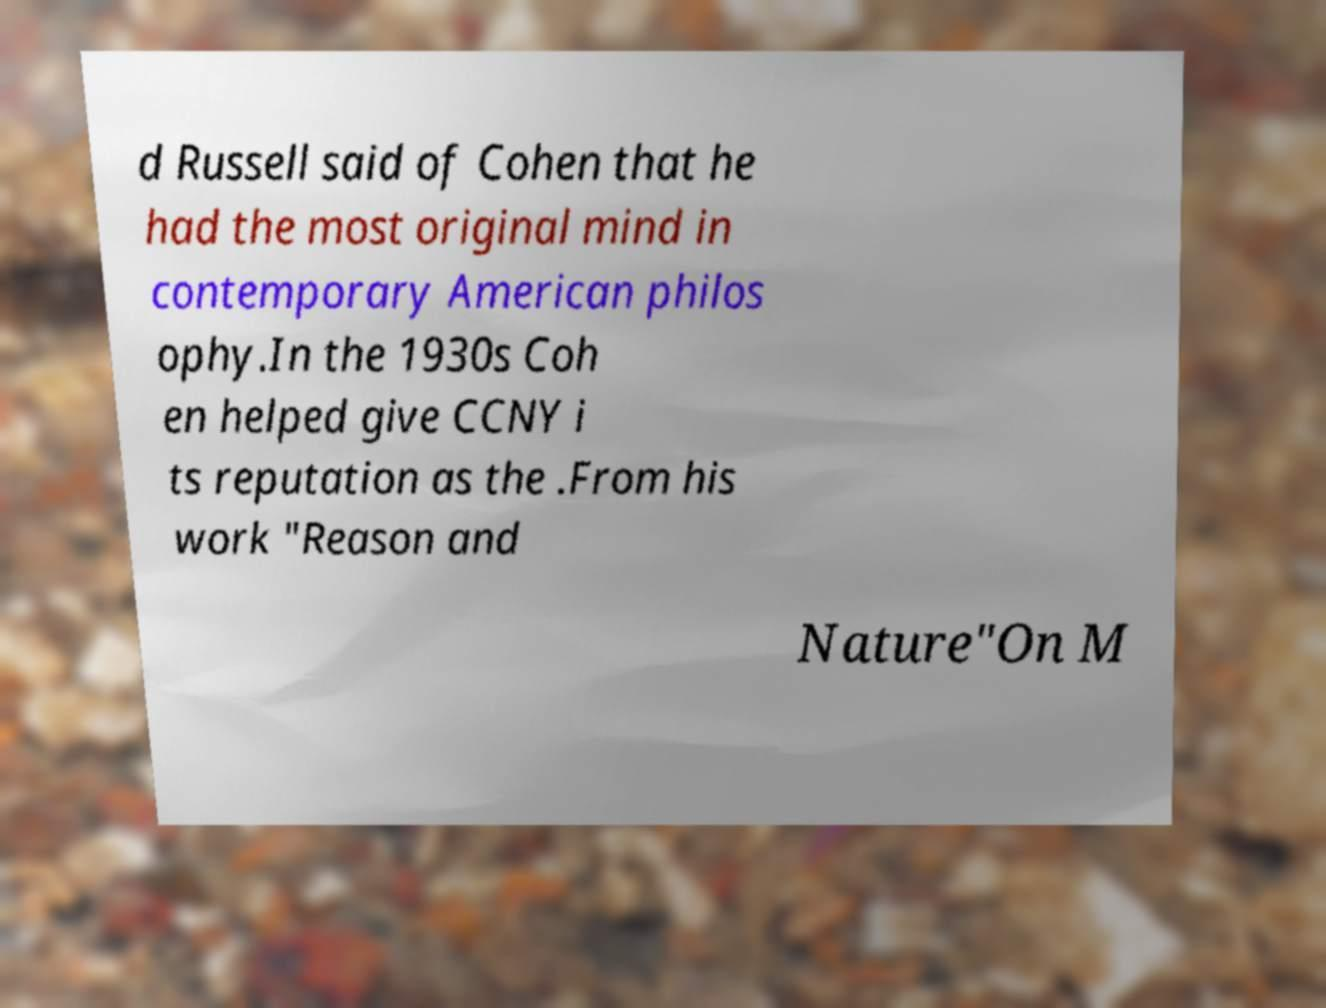Could you extract and type out the text from this image? d Russell said of Cohen that he had the most original mind in contemporary American philos ophy.In the 1930s Coh en helped give CCNY i ts reputation as the .From his work "Reason and Nature"On M 